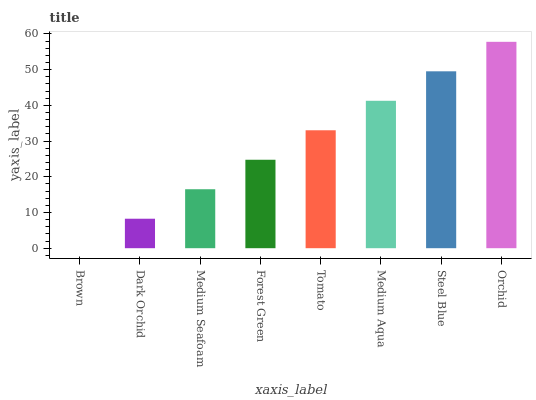Is Brown the minimum?
Answer yes or no. Yes. Is Orchid the maximum?
Answer yes or no. Yes. Is Dark Orchid the minimum?
Answer yes or no. No. Is Dark Orchid the maximum?
Answer yes or no. No. Is Dark Orchid greater than Brown?
Answer yes or no. Yes. Is Brown less than Dark Orchid?
Answer yes or no. Yes. Is Brown greater than Dark Orchid?
Answer yes or no. No. Is Dark Orchid less than Brown?
Answer yes or no. No. Is Tomato the high median?
Answer yes or no. Yes. Is Forest Green the low median?
Answer yes or no. Yes. Is Forest Green the high median?
Answer yes or no. No. Is Brown the low median?
Answer yes or no. No. 